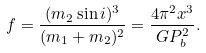<formula> <loc_0><loc_0><loc_500><loc_500>f = \frac { ( m _ { 2 } \sin i ) ^ { 3 } } { ( m _ { 1 } + m _ { 2 } ) ^ { 2 } } = \frac { 4 \pi ^ { 2 } x ^ { 3 } } { G P _ { b } ^ { 2 } } .</formula> 